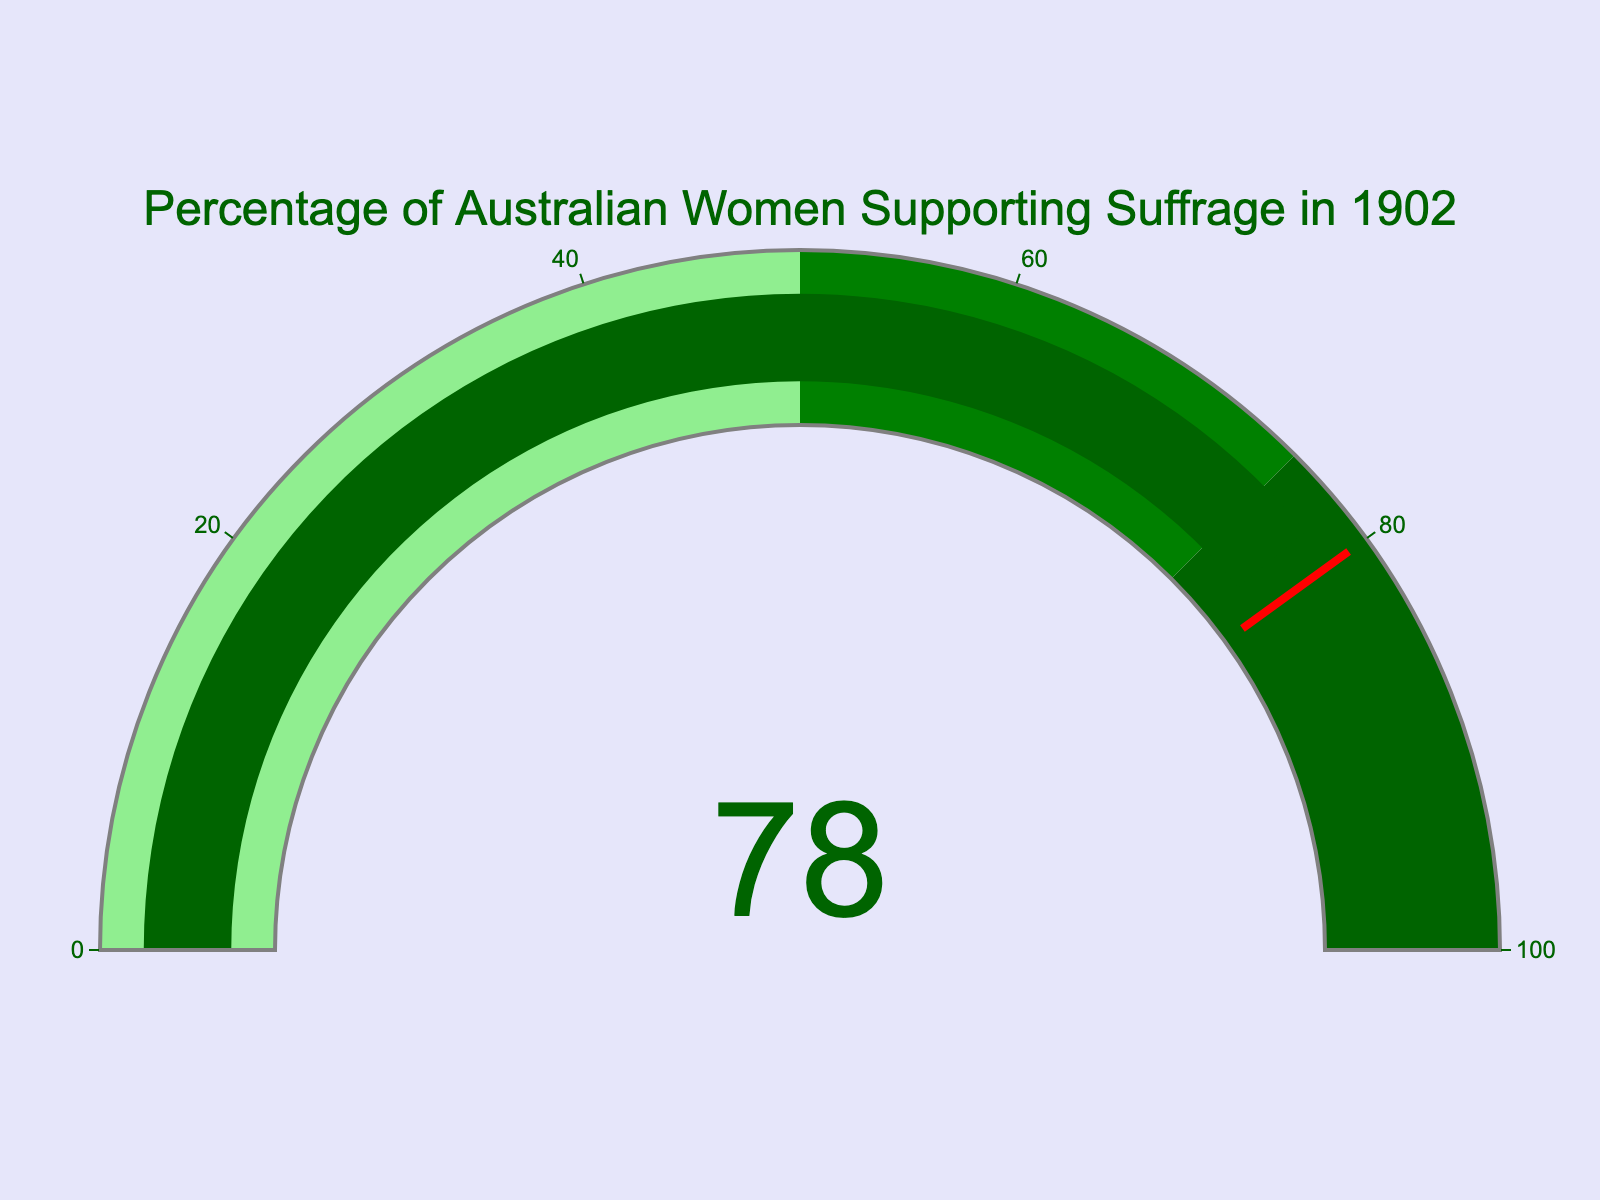What percentage of Australian women supported suffrage in 1902? The figure shows a gauge with a number indicating the percentage.
Answer: 78% What is the title of the gauge chart? The title is displayed at the top of the gauge chart.
Answer: Percentage of Australian Women Supporting Suffrage in 1902 What color represents the percentage range from 0 to 50? The color is shown as a part of the gauge.
Answer: Light green Which part of the gauge is the percentage marker positioned in? The percentage (78%) falls in the third segment, as the gauge is divided into ranges colored light green, green, and dark green.
Answer: Dark green Is the percentage of Australian women who supported suffrage above or below 75%? The gauge value of 78% is compared to 75%.
Answer: Above 75% How is the threshold marked on the gauge? The figure uses a red line across the gauge to indicate the threshold.
Answer: Red line Calculate the difference between the displayed percentage and the 100% mark. Subtract the given percentage (78%) from 100%. The difference is 100% - 78% = 22%
Answer: 22% What is the color of the text on the gauge indicating the value? The figure shows the text color.
Answer: Dark green What is the range covered by the green part of the gauge? The green section spans the range indicated by step boundaries.
Answer: 50 to 75 Is the background color of the gauge chart white or lavender? The paper background color is indicated in the figure description.
Answer: Lavender 